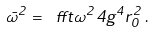Convert formula to latex. <formula><loc_0><loc_0><loc_500><loc_500>\bar { \omega } ^ { 2 } = \ f f t { \omega ^ { 2 } } { 4 g ^ { 4 } r _ { 0 } ^ { 2 } } \, .</formula> 